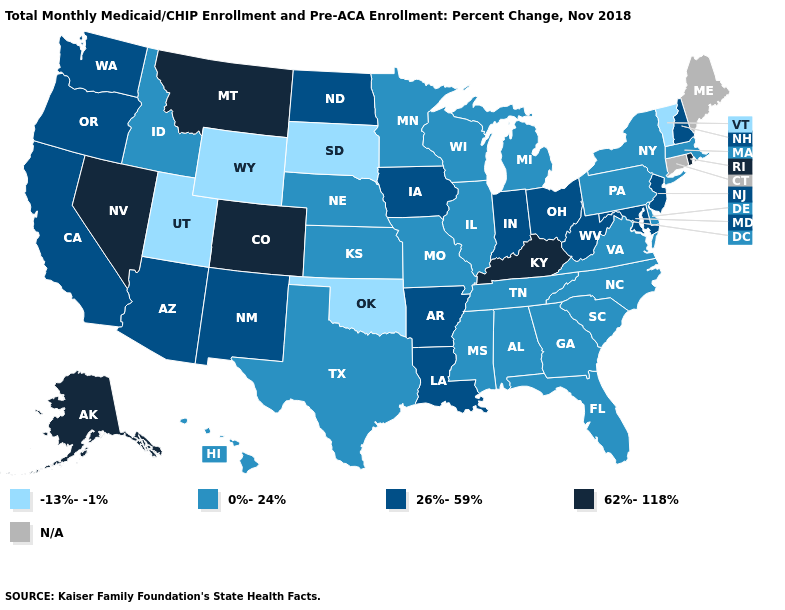What is the value of Arizona?
Concise answer only. 26%-59%. Name the states that have a value in the range 0%-24%?
Concise answer only. Alabama, Delaware, Florida, Georgia, Hawaii, Idaho, Illinois, Kansas, Massachusetts, Michigan, Minnesota, Mississippi, Missouri, Nebraska, New York, North Carolina, Pennsylvania, South Carolina, Tennessee, Texas, Virginia, Wisconsin. Which states hav the highest value in the Northeast?
Answer briefly. Rhode Island. Name the states that have a value in the range 0%-24%?
Quick response, please. Alabama, Delaware, Florida, Georgia, Hawaii, Idaho, Illinois, Kansas, Massachusetts, Michigan, Minnesota, Mississippi, Missouri, Nebraska, New York, North Carolina, Pennsylvania, South Carolina, Tennessee, Texas, Virginia, Wisconsin. Among the states that border Tennessee , does Missouri have the lowest value?
Keep it brief. Yes. Does Arkansas have the highest value in the South?
Keep it brief. No. What is the highest value in states that border North Dakota?
Write a very short answer. 62%-118%. Name the states that have a value in the range 26%-59%?
Concise answer only. Arizona, Arkansas, California, Indiana, Iowa, Louisiana, Maryland, New Hampshire, New Jersey, New Mexico, North Dakota, Ohio, Oregon, Washington, West Virginia. What is the value of Michigan?
Short answer required. 0%-24%. Name the states that have a value in the range N/A?
Keep it brief. Connecticut, Maine. Does Nevada have the highest value in the USA?
Answer briefly. Yes. Name the states that have a value in the range 0%-24%?
Give a very brief answer. Alabama, Delaware, Florida, Georgia, Hawaii, Idaho, Illinois, Kansas, Massachusetts, Michigan, Minnesota, Mississippi, Missouri, Nebraska, New York, North Carolina, Pennsylvania, South Carolina, Tennessee, Texas, Virginia, Wisconsin. Does Nevada have the highest value in the USA?
Concise answer only. Yes. 